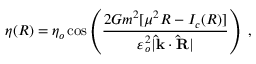<formula> <loc_0><loc_0><loc_500><loc_500>\eta ( R ) = \eta _ { o } \cos \left ( \frac { 2 G m ^ { 2 } [ \mu ^ { 2 } R - I _ { c } ( R ) ] } { \varepsilon _ { o } ^ { 2 } | \hat { k } \cdot \hat { R } | } \right ) \ ,</formula> 